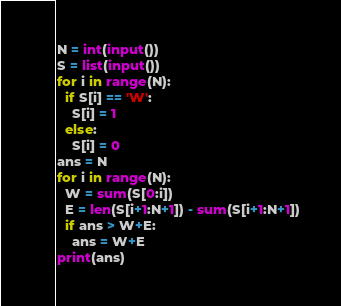<code> <loc_0><loc_0><loc_500><loc_500><_Python_>N = int(input())
S = list(input())
for i in range(N):
  if S[i] == 'W':
    S[i] = 1
  else:
    S[i] = 0
ans = N
for i in range(N):
  W = sum(S[0:i])
  E = len(S[i+1:N+1]) - sum(S[i+1:N+1])
  if ans > W+E:
    ans = W+E
print(ans)</code> 